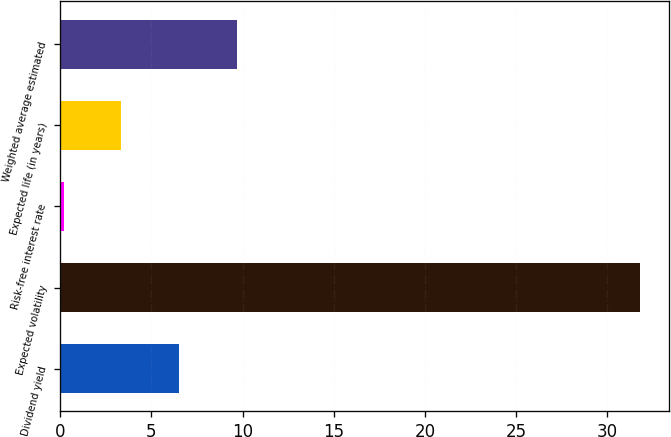Convert chart. <chart><loc_0><loc_0><loc_500><loc_500><bar_chart><fcel>Dividend yield<fcel>Expected volatility<fcel>Risk-free interest rate<fcel>Expected life (in years)<fcel>Weighted average estimated<nl><fcel>6.51<fcel>31.8<fcel>0.19<fcel>3.35<fcel>9.67<nl></chart> 